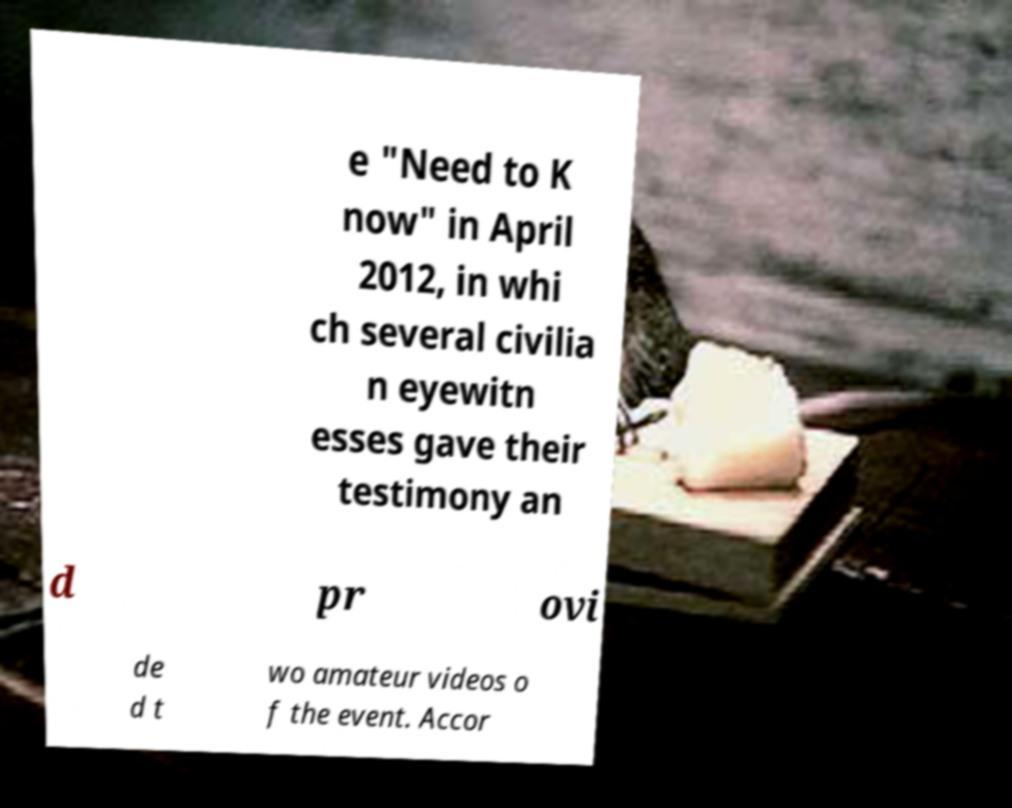Could you extract and type out the text from this image? e "Need to K now" in April 2012, in whi ch several civilia n eyewitn esses gave their testimony an d pr ovi de d t wo amateur videos o f the event. Accor 